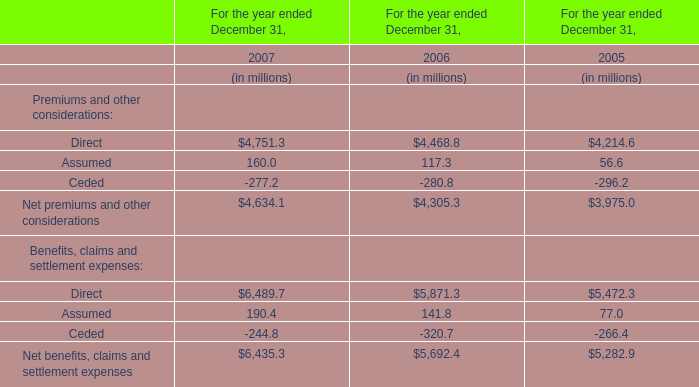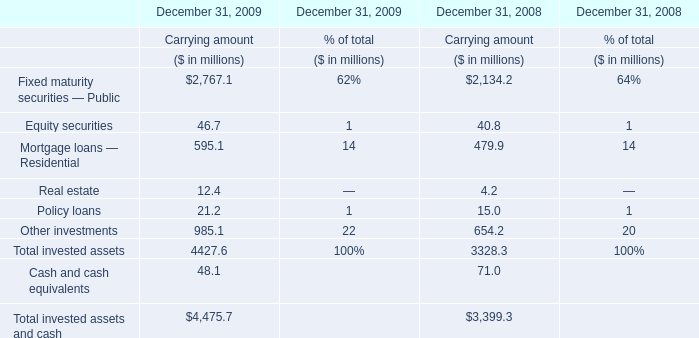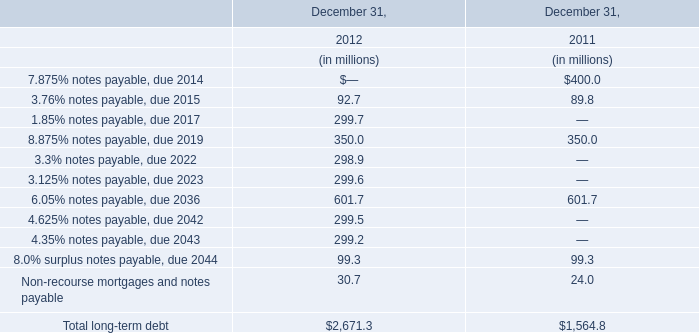What's the total amount of the Carrying amount in the year where Equity securities greater than 45? (in million) 
Answer: 4475.7. 